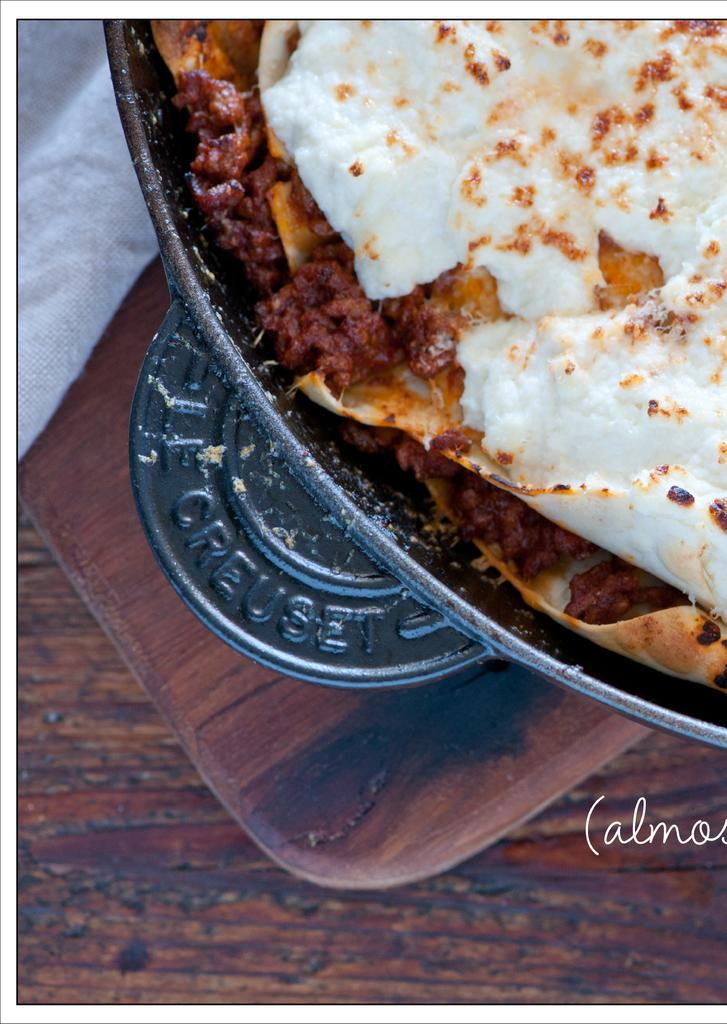What is on the plate in the image? There is food in the plate. Can you describe the colors of the food? The food has white, brown, and red colors. What is the color of the surface the plate is on? The plate is on a brown surface. How many pizzas are being sold at the shop in the image? There is no shop or pizzas present in the image; it only shows a plate of food with specific colors. What sound does the bell make in the image? There is no bell present in the image. 